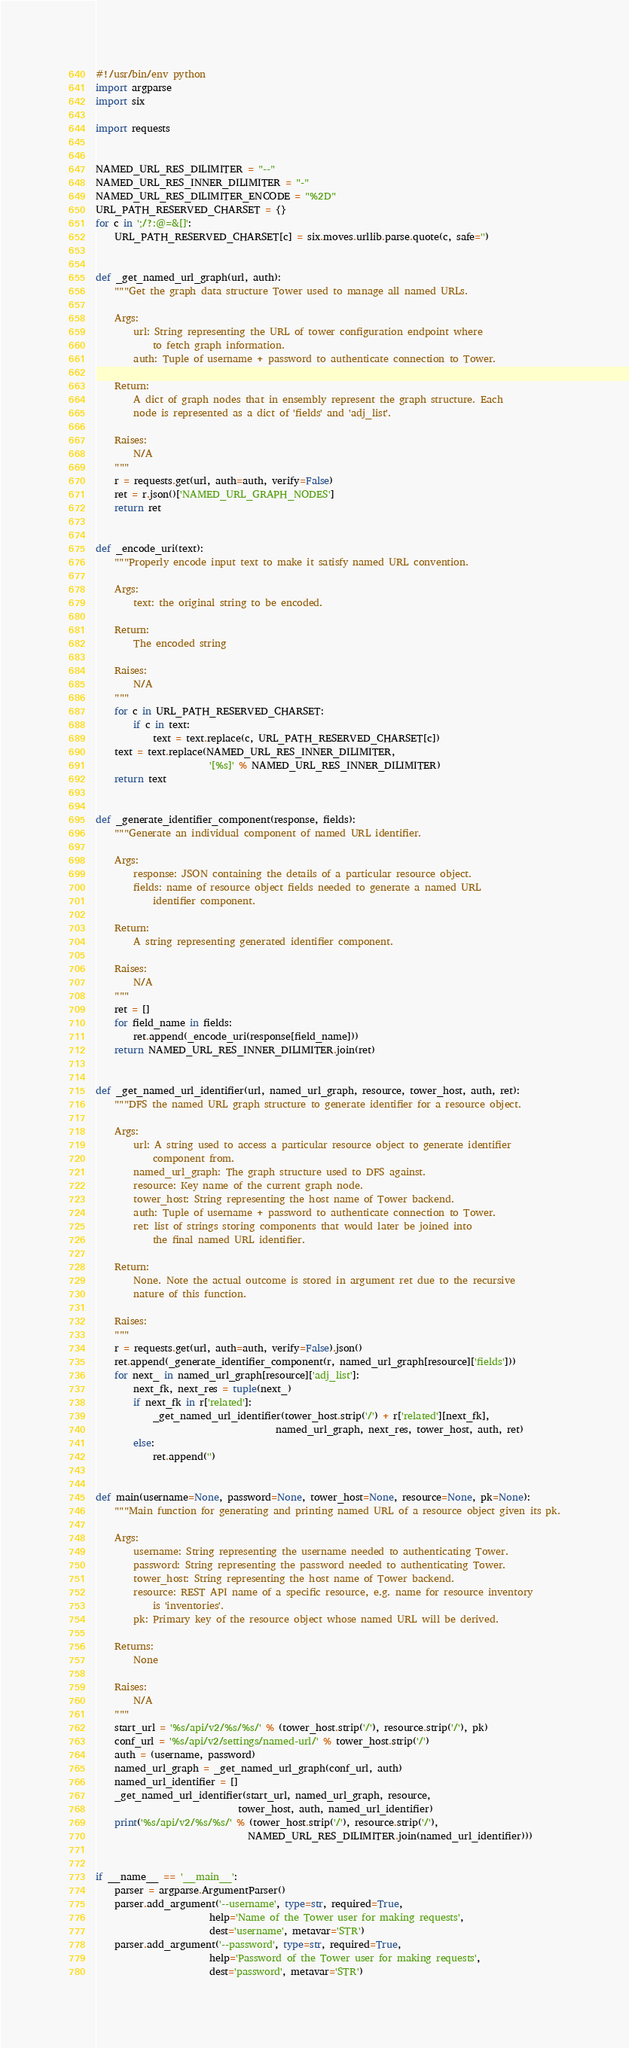<code> <loc_0><loc_0><loc_500><loc_500><_Python_>#!/usr/bin/env python
import argparse
import six

import requests


NAMED_URL_RES_DILIMITER = "--"
NAMED_URL_RES_INNER_DILIMITER = "-"
NAMED_URL_RES_DILIMITER_ENCODE = "%2D"
URL_PATH_RESERVED_CHARSET = {}
for c in ';/?:@=&[]':
    URL_PATH_RESERVED_CHARSET[c] = six.moves.urllib.parse.quote(c, safe='')


def _get_named_url_graph(url, auth):
    """Get the graph data structure Tower used to manage all named URLs.

    Args:
        url: String representing the URL of tower configuration endpoint where
            to fetch graph information.
        auth: Tuple of username + password to authenticate connection to Tower.

    Return:
        A dict of graph nodes that in ensembly represent the graph structure. Each
        node is represented as a dict of 'fields' and 'adj_list'.

    Raises:
        N/A
    """
    r = requests.get(url, auth=auth, verify=False)
    ret = r.json()['NAMED_URL_GRAPH_NODES']
    return ret


def _encode_uri(text):
    """Properly encode input text to make it satisfy named URL convention.

    Args:
        text: the original string to be encoded.

    Return:
        The encoded string

    Raises:
        N/A
    """
    for c in URL_PATH_RESERVED_CHARSET:
        if c in text:
            text = text.replace(c, URL_PATH_RESERVED_CHARSET[c])
    text = text.replace(NAMED_URL_RES_INNER_DILIMITER,
                        '[%s]' % NAMED_URL_RES_INNER_DILIMITER)
    return text


def _generate_identifier_component(response, fields):
    """Generate an individual component of named URL identifier.

    Args:
        response: JSON containing the details of a particular resource object.
        fields: name of resource object fields needed to generate a named URL
            identifier component.

    Return:
        A string representing generated identifier component.

    Raises:
        N/A
    """
    ret = []
    for field_name in fields:
        ret.append(_encode_uri(response[field_name]))
    return NAMED_URL_RES_INNER_DILIMITER.join(ret)


def _get_named_url_identifier(url, named_url_graph, resource, tower_host, auth, ret):
    """DFS the named URL graph structure to generate identifier for a resource object.

    Args:
        url: A string used to access a particular resource object to generate identifier
            component from.
        named_url_graph: The graph structure used to DFS against.
        resource: Key name of the current graph node.
        tower_host: String representing the host name of Tower backend.
        auth: Tuple of username + password to authenticate connection to Tower.
        ret: list of strings storing components that would later be joined into
            the final named URL identifier.

    Return:
        None. Note the actual outcome is stored in argument ret due to the recursive
        nature of this function.

    Raises:
    """
    r = requests.get(url, auth=auth, verify=False).json()
    ret.append(_generate_identifier_component(r, named_url_graph[resource]['fields']))
    for next_ in named_url_graph[resource]['adj_list']:
        next_fk, next_res = tuple(next_)
        if next_fk in r['related']:
            _get_named_url_identifier(tower_host.strip('/') + r['related'][next_fk],
                                      named_url_graph, next_res, tower_host, auth, ret)
        else:
            ret.append('')


def main(username=None, password=None, tower_host=None, resource=None, pk=None):
    """Main function for generating and printing named URL of a resource object given its pk.

    Args:
        username: String representing the username needed to authenticating Tower.
        password: String representing the password needed to authenticating Tower.
        tower_host: String representing the host name of Tower backend.
        resource: REST API name of a specific resource, e.g. name for resource inventory
            is 'inventories'.
        pk: Primary key of the resource object whose named URL will be derived.

    Returns:
        None

    Raises:
        N/A
    """
    start_url = '%s/api/v2/%s/%s/' % (tower_host.strip('/'), resource.strip('/'), pk)
    conf_url = '%s/api/v2/settings/named-url/' % tower_host.strip('/')
    auth = (username, password)
    named_url_graph = _get_named_url_graph(conf_url, auth)
    named_url_identifier = []
    _get_named_url_identifier(start_url, named_url_graph, resource,
                              tower_host, auth, named_url_identifier)
    print('%s/api/v2/%s/%s/' % (tower_host.strip('/'), resource.strip('/'),
                                NAMED_URL_RES_DILIMITER.join(named_url_identifier)))


if __name__ == '__main__':
    parser = argparse.ArgumentParser()
    parser.add_argument('--username', type=str, required=True,
                        help='Name of the Tower user for making requests',
                        dest='username', metavar='STR')
    parser.add_argument('--password', type=str, required=True,
                        help='Password of the Tower user for making requests',
                        dest='password', metavar='STR')</code> 